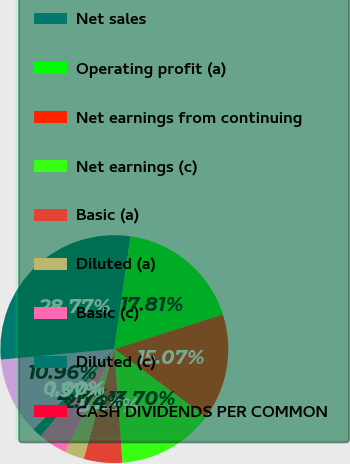Convert chart. <chart><loc_0><loc_0><loc_500><loc_500><pie_chart><fcel>(In millions except per share<fcel>Net sales<fcel>Operating profit (a)<fcel>Net earnings from continuing<fcel>Net earnings (c)<fcel>Basic (a)<fcel>Diluted (a)<fcel>Basic (c)<fcel>Diluted (c)<fcel>CASH DIVIDENDS PER COMMON<nl><fcel>10.96%<fcel>28.77%<fcel>17.81%<fcel>15.07%<fcel>13.7%<fcel>5.48%<fcel>2.74%<fcel>4.11%<fcel>1.37%<fcel>0.0%<nl></chart> 